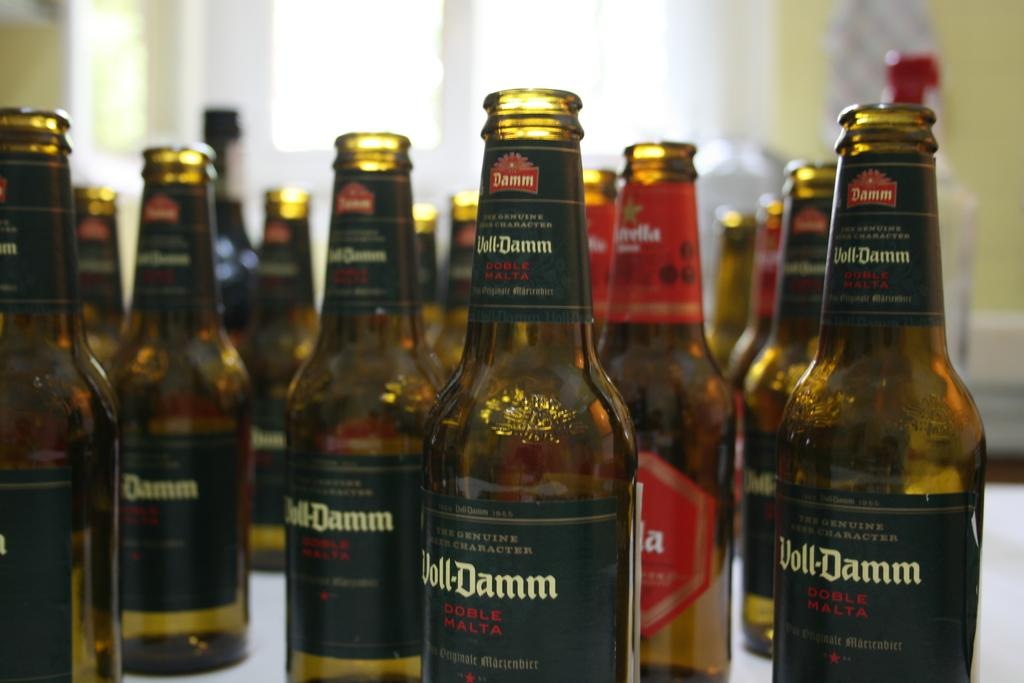What type of objects are visible in the image? There are glass bottles in the image. What can be found on the glass bottles? The glass bottles have labels on them. What color is the sweater worn by the person holding the glass bottles in the image? There is no person holding the glass bottles in the image, and therefore no sweater can be observed. 